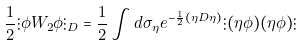Convert formula to latex. <formula><loc_0><loc_0><loc_500><loc_500>\frac { 1 } { 2 } \vdots \phi W _ { 2 } \phi \vdots _ { D } = \frac { 1 } { 2 } \int d \sigma _ { \eta } e ^ { - \frac { 1 } { 2 } ( \eta D \eta ) } \vdots ( \eta \phi ) ( \eta \phi ) \vdots</formula> 